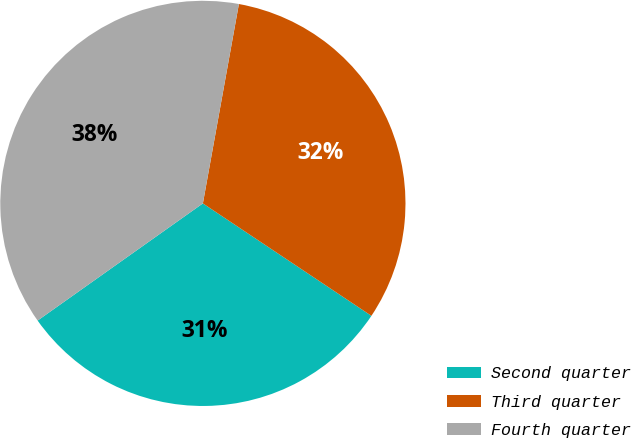Convert chart. <chart><loc_0><loc_0><loc_500><loc_500><pie_chart><fcel>Second quarter<fcel>Third quarter<fcel>Fourth quarter<nl><fcel>30.82%<fcel>31.52%<fcel>37.66%<nl></chart> 